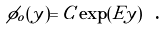Convert formula to latex. <formula><loc_0><loc_0><loc_500><loc_500>\phi _ { o } ( y ) = C \exp ( E y ) \text { .}</formula> 